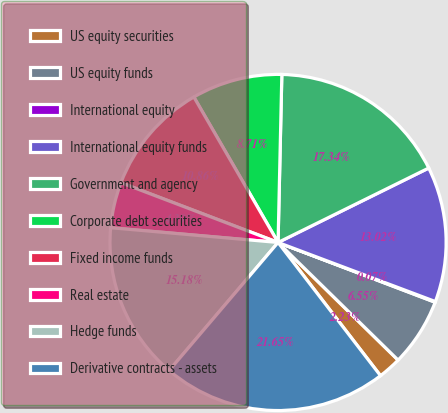Convert chart. <chart><loc_0><loc_0><loc_500><loc_500><pie_chart><fcel>US equity securities<fcel>US equity funds<fcel>International equity<fcel>International equity funds<fcel>Government and agency<fcel>Corporate debt securities<fcel>Fixed income funds<fcel>Real estate<fcel>Hedge funds<fcel>Derivative contracts - assets<nl><fcel>2.23%<fcel>6.55%<fcel>0.07%<fcel>13.02%<fcel>17.34%<fcel>8.71%<fcel>10.86%<fcel>4.39%<fcel>15.18%<fcel>21.65%<nl></chart> 